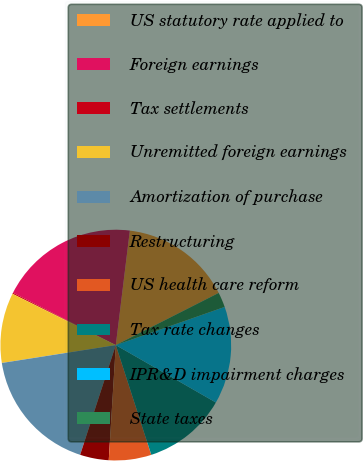<chart> <loc_0><loc_0><loc_500><loc_500><pie_chart><fcel>US statutory rate applied to<fcel>Foreign earnings<fcel>Tax settlements<fcel>Unremitted foreign earnings<fcel>Amortization of purchase<fcel>Restructuring<fcel>US health care reform<fcel>Tax rate changes<fcel>IPR&D impairment charges<fcel>State taxes<nl><fcel>15.59%<fcel>19.44%<fcel>0.17%<fcel>9.81%<fcel>17.52%<fcel>4.03%<fcel>5.95%<fcel>11.73%<fcel>13.66%<fcel>2.1%<nl></chart> 